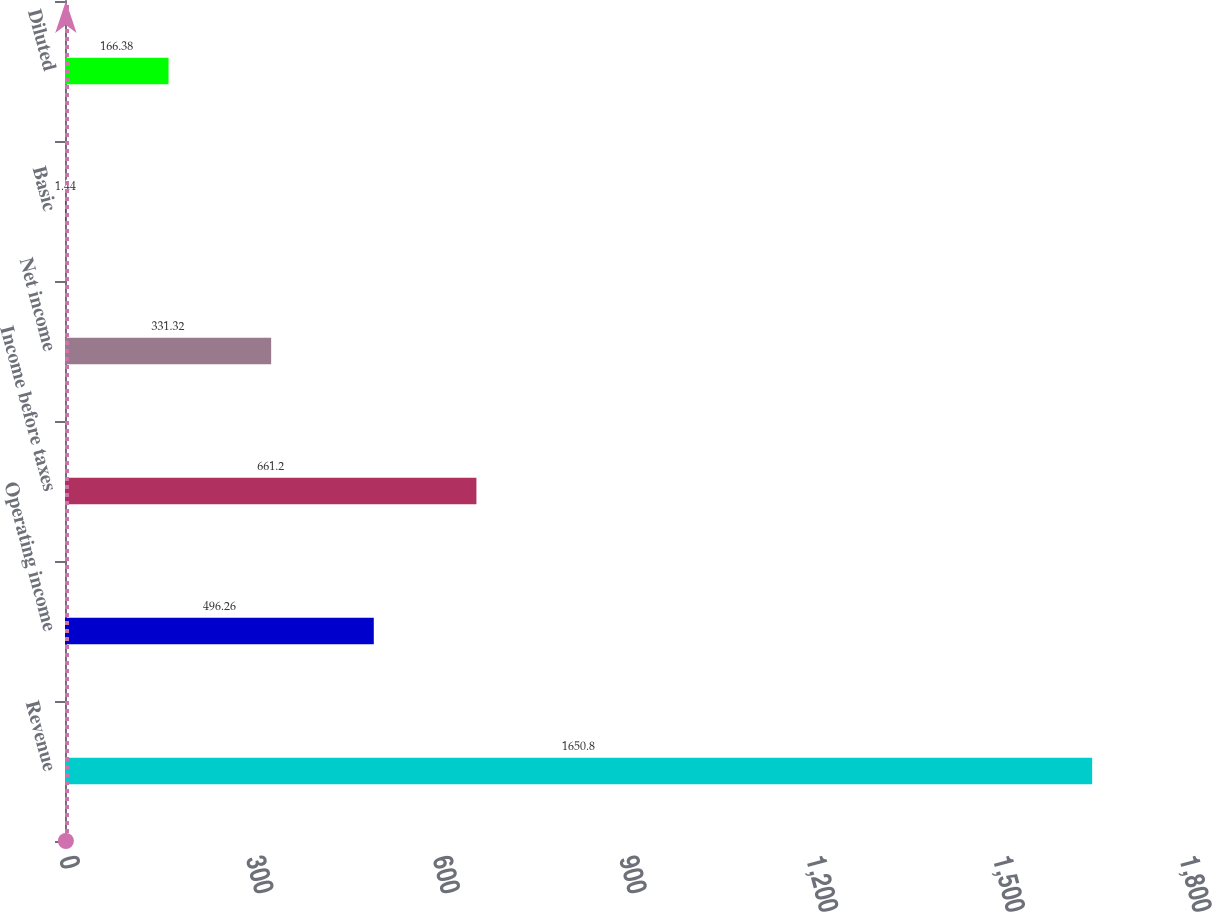<chart> <loc_0><loc_0><loc_500><loc_500><bar_chart><fcel>Revenue<fcel>Operating income<fcel>Income before taxes<fcel>Net income<fcel>Basic<fcel>Diluted<nl><fcel>1650.8<fcel>496.26<fcel>661.2<fcel>331.32<fcel>1.44<fcel>166.38<nl></chart> 